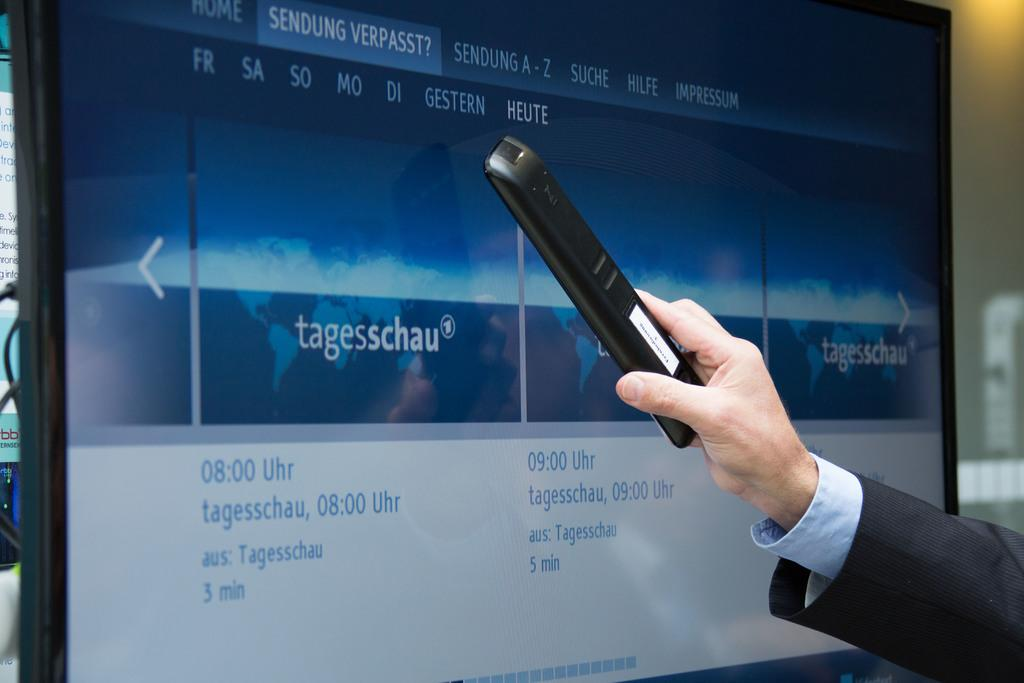What is the person holding in the image? There is a person's hand holding a remote in the image. What can be seen behind the person's hand? There is a screen in the background of the image. What is displayed on the screen? Text is visible on the screen. What is the background setting of the image? There is there a wall visible? What type of glue is being used to hold the remote in the image? There is no glue present in the image; the remote is being held by a person's hand. What time of day is it in the image, and is it related to the drain? The time of day is not mentioned in the image, and there is no reference to a drain. 